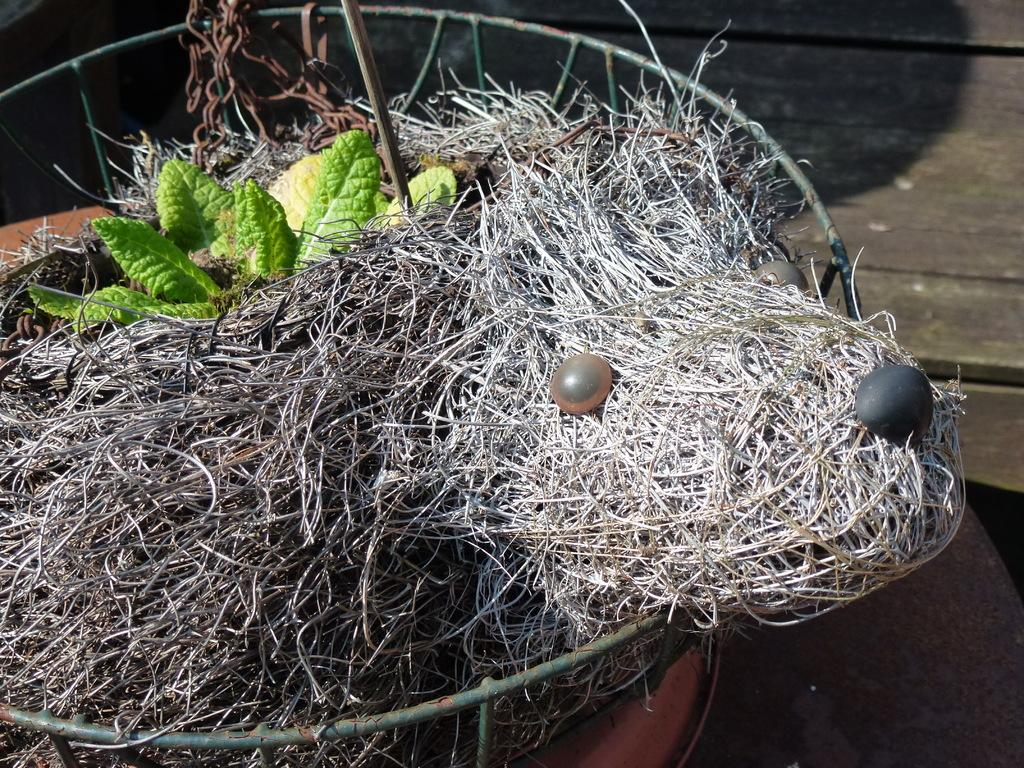What can be found in the image? There is a nest in the image. What is inside the nest? There are two eggs in the nest. What type of vegetation can be seen in the image? There are leaves visible at the top of the image. What type of insurance policy is being discussed in the image? There is no discussion of insurance policies in the image; it features a nest with two eggs and leaves at the top. 